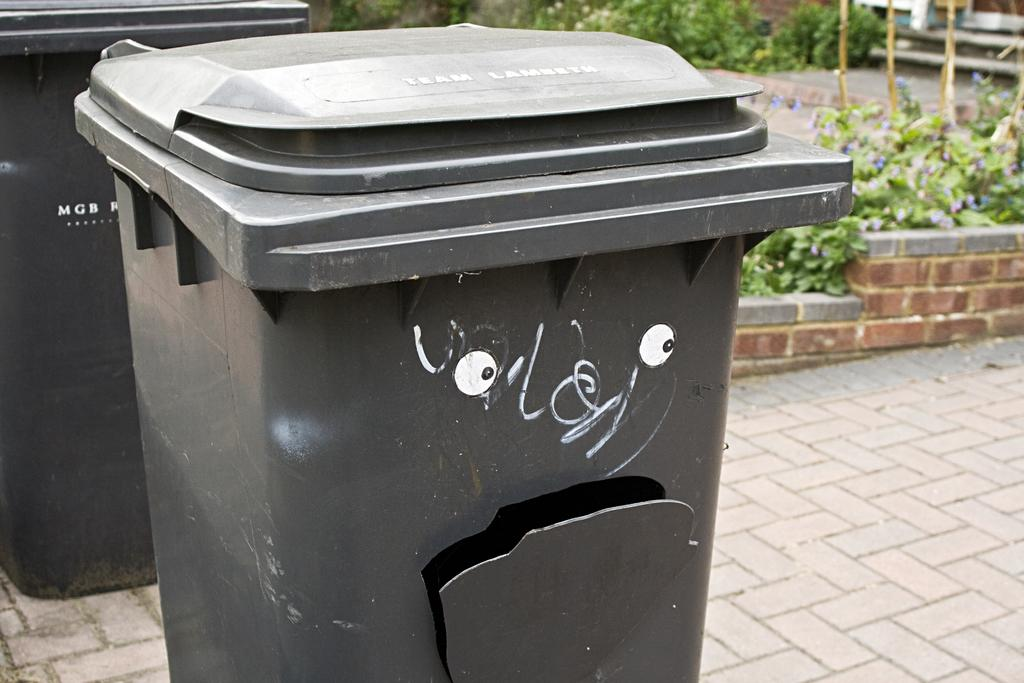How many dustbins can be seen in the image? There are 2 dustbins in the image. What color are the dustbins? The dustbins are grey in color. What is located on the right side of the image? There is a staircase on the right side of the image. What type of vegetation is present in the image? There are plants in the image. What type of can is visible on the staircase in the image? There is no can visible on the staircase in the image. Is there a gate present in the image? No, there is no gate present in the image. How many potatoes can be seen in the image? There are no potatoes present in the image. 